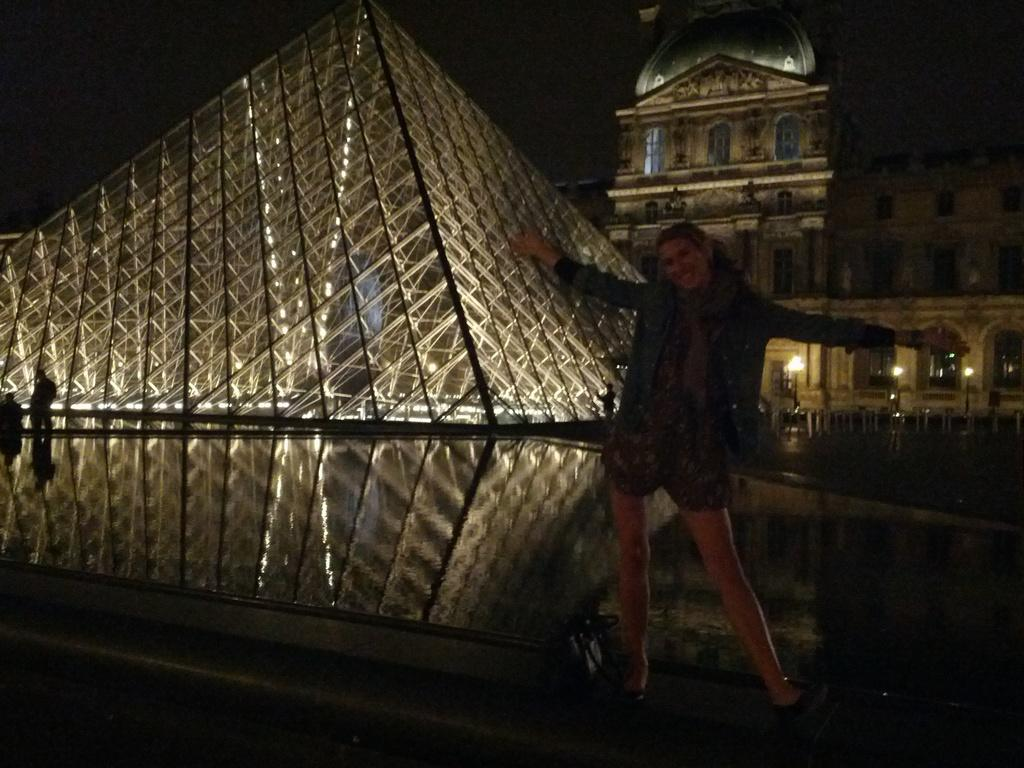What is the woman doing in the image? The woman is standing on a platform in the image. What object can be seen near the woman? There is a bag in the image. What can be seen in the distance behind the woman? There are buildings and lights visible in the background of the image. What part of the natural environment is visible in the image? The sky is visible in the background of the image. How many roses are on the shelf in the image? There is no shelf or rose present in the image. What is the amount of money the woman is holding in the image? There is no indication of money or any financial transaction in the image. 